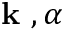Convert formula to latex. <formula><loc_0><loc_0><loc_500><loc_500>k , \alpha</formula> 